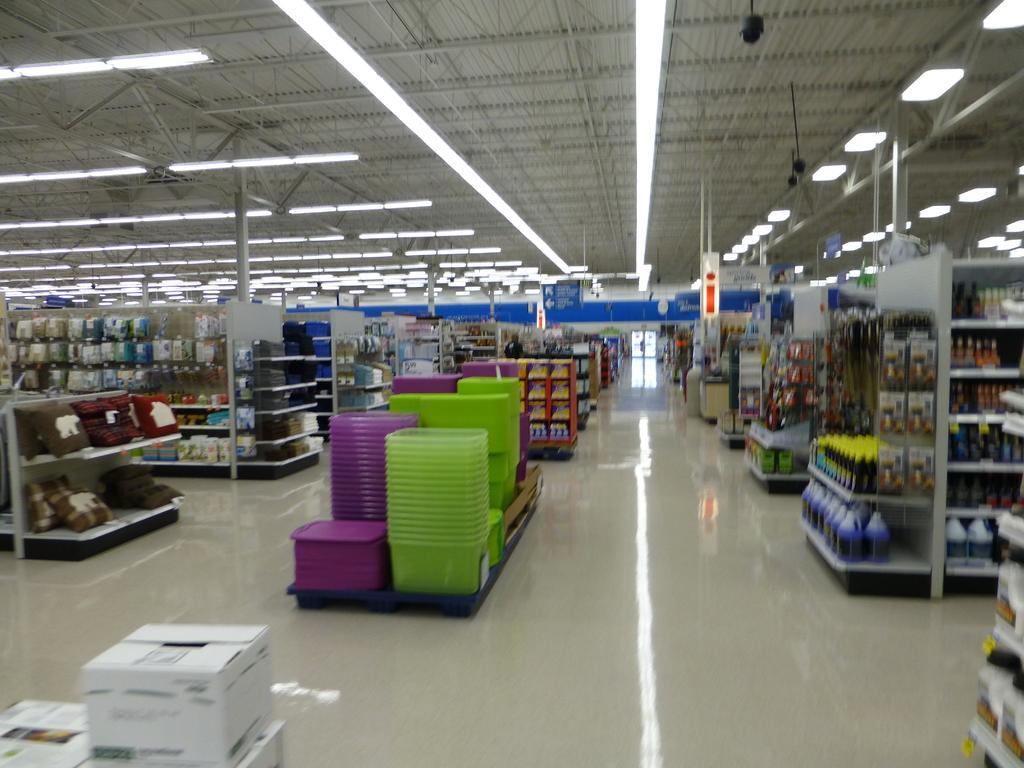In one or two sentences, can you explain what this image depicts? In this image we can see a view from inside of a supermarket. There are boxes and baskets. There are racks. On the racks there are bottles, packets and many other items. On the ceiling there are lights. In the background it is blur. 